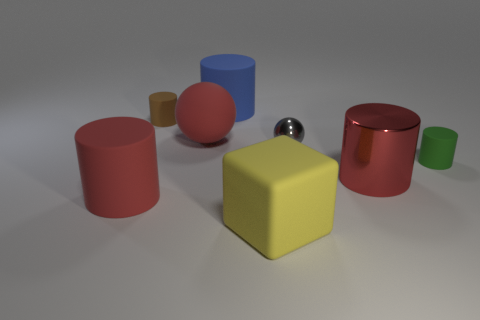Subtract 1 cylinders. How many cylinders are left? 4 Subtract all brown rubber cylinders. How many cylinders are left? 4 Subtract all brown cylinders. How many cylinders are left? 4 Subtract all purple cylinders. Subtract all purple spheres. How many cylinders are left? 5 Add 1 tiny shiny objects. How many objects exist? 9 Subtract all cylinders. How many objects are left? 3 Add 1 small gray balls. How many small gray balls are left? 2 Add 7 large yellow rubber objects. How many large yellow rubber objects exist? 8 Subtract 1 yellow cubes. How many objects are left? 7 Subtract all big metallic things. Subtract all green rubber cylinders. How many objects are left? 6 